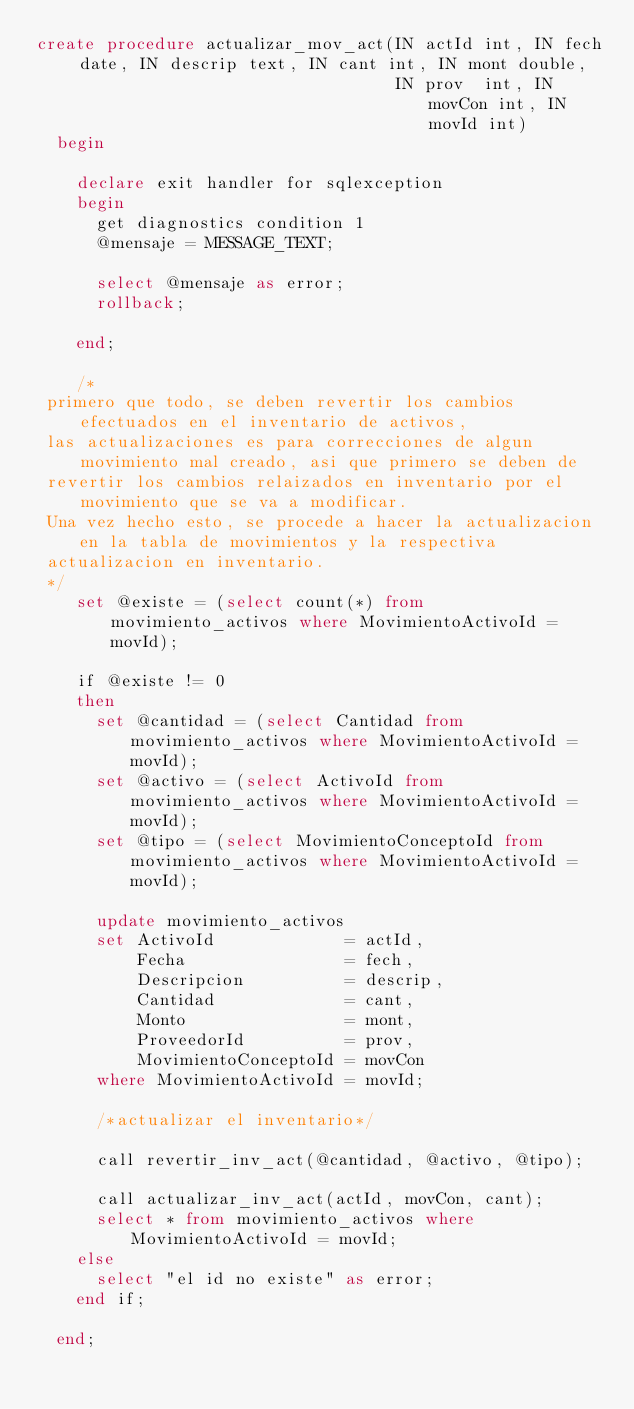Convert code to text. <code><loc_0><loc_0><loc_500><loc_500><_SQL_>create procedure actualizar_mov_act(IN actId int, IN fech date, IN descrip text, IN cant int, IN mont double,
                                    IN prov  int, IN movCon int, IN movId int)
  begin

    declare exit handler for sqlexception
    begin
      get diagnostics condition 1
      @mensaje = MESSAGE_TEXT;

      select @mensaje as error;
      rollback;

    end;

    /*
 primero que todo, se deben revertir los cambios efectuados en el inventario de activos,
 las actualizaciones es para correcciones de algun movimiento mal creado, asi que primero se deben de
 revertir los cambios relaizados en inventario por el movimiento que se va a modificar.
 Una vez hecho esto, se procede a hacer la actualizacion en la tabla de movimientos y la respectiva
 actualizacion en inventario.
 */
    set @existe = (select count(*) from movimiento_activos where MovimientoActivoId = movId);

    if @existe != 0
    then
      set @cantidad = (select Cantidad from movimiento_activos where MovimientoActivoId = movId);
      set @activo = (select ActivoId from movimiento_activos where MovimientoActivoId = movId);
      set @tipo = (select MovimientoConceptoId from movimiento_activos where MovimientoActivoId = movId);

      update movimiento_activos
      set ActivoId             = actId,
          Fecha                = fech,
          Descripcion          = descrip,
          Cantidad             = cant,
          Monto                = mont,
          ProveedorId          = prov,
          MovimientoConceptoId = movCon
      where MovimientoActivoId = movId;

      /*actualizar el inventario*/

      call revertir_inv_act(@cantidad, @activo, @tipo);

      call actualizar_inv_act(actId, movCon, cant);
      select * from movimiento_activos where MovimientoActivoId = movId;
    else
      select "el id no existe" as error;
    end if;

  end;


</code> 